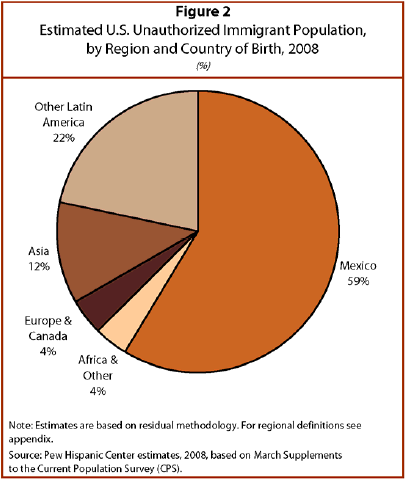Identify some key points in this picture. The sum of illegal immigrants from Mexico and Asia is 0.71. Mexico is the number one country/region in the chart. 